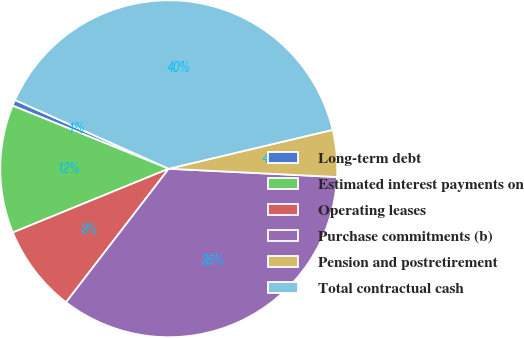Convert chart. <chart><loc_0><loc_0><loc_500><loc_500><pie_chart><fcel>Long-term debt<fcel>Estimated interest payments on<fcel>Operating leases<fcel>Purchase commitments (b)<fcel>Pension and postretirement<fcel>Total contractual cash<nl><fcel>0.58%<fcel>12.29%<fcel>8.39%<fcel>34.65%<fcel>4.49%<fcel>39.6%<nl></chart> 